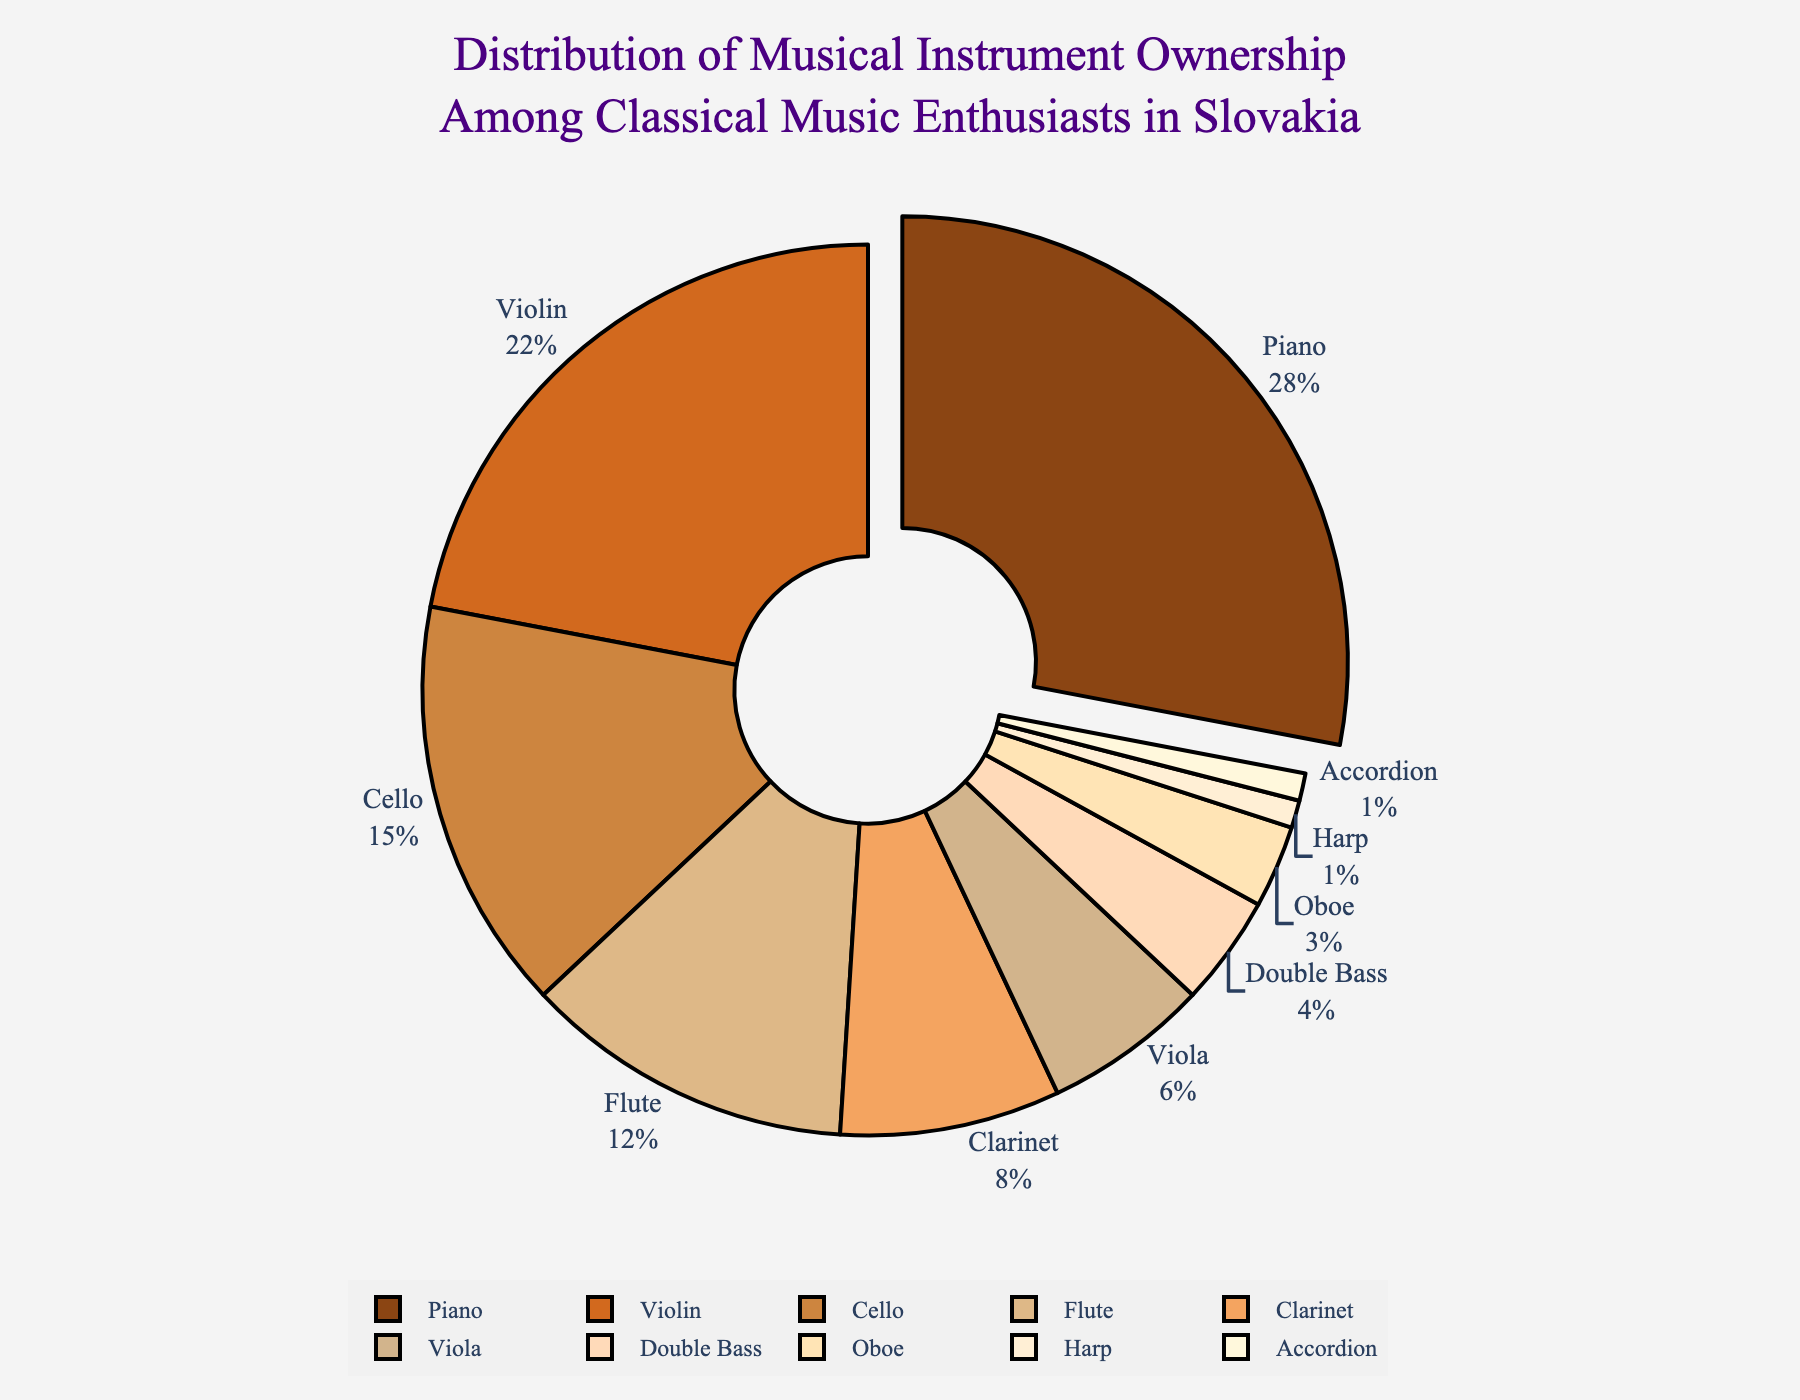How many instruments have ownership percentages less than 10%? Identify the instruments with percentages under 10%: Clarinet (8%), Viola (6%), Double Bass (4%), Oboe (3%), Harp (1%), Accordion (1%). Count these instruments.
Answer: 6 What percentage of classical music enthusiasts own either a Piano or a Violin? Look at the percentages for Piano (28%) and Violin (22%). Sum these percentages: 28% + 22%.
Answer: 50% Which instrument has the lowest ownership percentage and what is it? Identify the instrument with the smallest percentage value in the chart.
Answer: Harp and Accordion, 1% How does the ownership percentage of Flute compare to that of Clarinet? Compare the percentage values for Flute (12%) and Clarinet (8%). Flute's percentage is higher.
Answer: Flute has a higher percentage What are the three most owned instruments and their combined percentage? Identify the top three instruments by percentage: Piano (28%), Violin (22%), and Cello (15%). Sum these percentages: 28% + 22% + 15%.
Answer: 65% Which instrument has ownership just below the halfway mark on the pie chart, and what is its percentage? Look at instruments closest to the 50% mark cumulatively, focusing on the highest near the halfway. Violin has 22%, putting Piano and Violin at 50%.
Answer: Violin, 22% What is the difference in ownership percentage between the Piano and the Double Bass? Subtract the Double Bass percentage (4%) from the Piano percentage (28%): 28% - 4%.
Answer: 24% If the percentage of Harp and Accordion owners were combined, would it exceed any other single instrument's ownership? Add Harp's and Accordion's percentages: 1% + 1% = 2%. Compare with other single percentages. No single instrument has ownership less than 2%.
Answer: No What percentage of enthusiasts own neither a Piano, Violin, nor a Cello? The rest of the instruments' ownership percentages are calculated by subtracting the combined percentage of Piano (28%), Violin (22%), and Cello (15%) from 100%. 100% - 65%.
Answer: 35% How does the color of the segment with the highest percentage compare visually to the segment with the lowest percentage? The Piano segment (highest) is brownish (28%), and the Harp and Accordion segments (lowest) are light yellowish (1%). Brown is visually distinct and dominant compared to light yellowish.
Answer: Brownish (Piano) is more visually dominant than light yellowish (Harp, Accordion) 